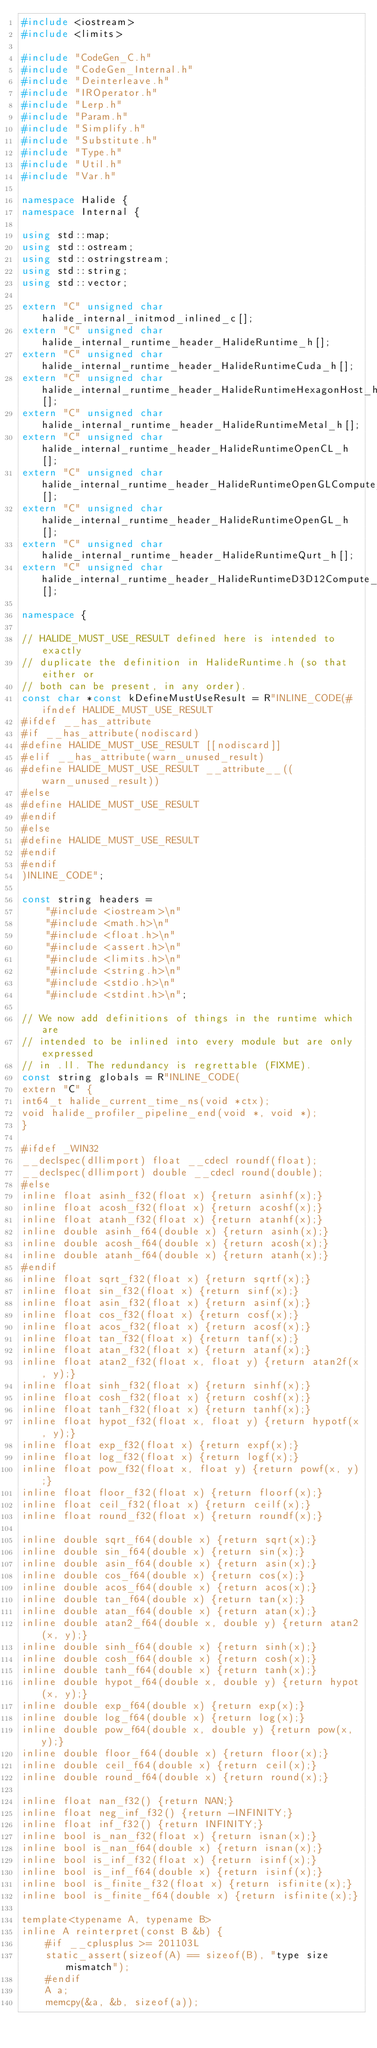Convert code to text. <code><loc_0><loc_0><loc_500><loc_500><_C++_>#include <iostream>
#include <limits>

#include "CodeGen_C.h"
#include "CodeGen_Internal.h"
#include "Deinterleave.h"
#include "IROperator.h"
#include "Lerp.h"
#include "Param.h"
#include "Simplify.h"
#include "Substitute.h"
#include "Type.h"
#include "Util.h"
#include "Var.h"

namespace Halide {
namespace Internal {

using std::map;
using std::ostream;
using std::ostringstream;
using std::string;
using std::vector;

extern "C" unsigned char halide_internal_initmod_inlined_c[];
extern "C" unsigned char halide_internal_runtime_header_HalideRuntime_h[];
extern "C" unsigned char halide_internal_runtime_header_HalideRuntimeCuda_h[];
extern "C" unsigned char halide_internal_runtime_header_HalideRuntimeHexagonHost_h[];
extern "C" unsigned char halide_internal_runtime_header_HalideRuntimeMetal_h[];
extern "C" unsigned char halide_internal_runtime_header_HalideRuntimeOpenCL_h[];
extern "C" unsigned char halide_internal_runtime_header_HalideRuntimeOpenGLCompute_h[];
extern "C" unsigned char halide_internal_runtime_header_HalideRuntimeOpenGL_h[];
extern "C" unsigned char halide_internal_runtime_header_HalideRuntimeQurt_h[];
extern "C" unsigned char halide_internal_runtime_header_HalideRuntimeD3D12Compute_h[];

namespace {

// HALIDE_MUST_USE_RESULT defined here is intended to exactly
// duplicate the definition in HalideRuntime.h (so that either or
// both can be present, in any order).
const char *const kDefineMustUseResult = R"INLINE_CODE(#ifndef HALIDE_MUST_USE_RESULT
#ifdef __has_attribute
#if __has_attribute(nodiscard)
#define HALIDE_MUST_USE_RESULT [[nodiscard]]
#elif __has_attribute(warn_unused_result)
#define HALIDE_MUST_USE_RESULT __attribute__((warn_unused_result))
#else
#define HALIDE_MUST_USE_RESULT
#endif
#else
#define HALIDE_MUST_USE_RESULT
#endif
#endif
)INLINE_CODE";

const string headers =
    "#include <iostream>\n"
    "#include <math.h>\n"
    "#include <float.h>\n"
    "#include <assert.h>\n"
    "#include <limits.h>\n"
    "#include <string.h>\n"
    "#include <stdio.h>\n"
    "#include <stdint.h>\n";

// We now add definitions of things in the runtime which are
// intended to be inlined into every module but are only expressed
// in .ll. The redundancy is regrettable (FIXME).
const string globals = R"INLINE_CODE(
extern "C" {
int64_t halide_current_time_ns(void *ctx);
void halide_profiler_pipeline_end(void *, void *);
}

#ifdef _WIN32
__declspec(dllimport) float __cdecl roundf(float);
__declspec(dllimport) double __cdecl round(double);
#else
inline float asinh_f32(float x) {return asinhf(x);}
inline float acosh_f32(float x) {return acoshf(x);}
inline float atanh_f32(float x) {return atanhf(x);}
inline double asinh_f64(double x) {return asinh(x);}
inline double acosh_f64(double x) {return acosh(x);}
inline double atanh_f64(double x) {return atanh(x);}
#endif
inline float sqrt_f32(float x) {return sqrtf(x);}
inline float sin_f32(float x) {return sinf(x);}
inline float asin_f32(float x) {return asinf(x);}
inline float cos_f32(float x) {return cosf(x);}
inline float acos_f32(float x) {return acosf(x);}
inline float tan_f32(float x) {return tanf(x);}
inline float atan_f32(float x) {return atanf(x);}
inline float atan2_f32(float x, float y) {return atan2f(x, y);}
inline float sinh_f32(float x) {return sinhf(x);}
inline float cosh_f32(float x) {return coshf(x);}
inline float tanh_f32(float x) {return tanhf(x);}
inline float hypot_f32(float x, float y) {return hypotf(x, y);}
inline float exp_f32(float x) {return expf(x);}
inline float log_f32(float x) {return logf(x);}
inline float pow_f32(float x, float y) {return powf(x, y);}
inline float floor_f32(float x) {return floorf(x);}
inline float ceil_f32(float x) {return ceilf(x);}
inline float round_f32(float x) {return roundf(x);}

inline double sqrt_f64(double x) {return sqrt(x);}
inline double sin_f64(double x) {return sin(x);}
inline double asin_f64(double x) {return asin(x);}
inline double cos_f64(double x) {return cos(x);}
inline double acos_f64(double x) {return acos(x);}
inline double tan_f64(double x) {return tan(x);}
inline double atan_f64(double x) {return atan(x);}
inline double atan2_f64(double x, double y) {return atan2(x, y);}
inline double sinh_f64(double x) {return sinh(x);}
inline double cosh_f64(double x) {return cosh(x);}
inline double tanh_f64(double x) {return tanh(x);}
inline double hypot_f64(double x, double y) {return hypot(x, y);}
inline double exp_f64(double x) {return exp(x);}
inline double log_f64(double x) {return log(x);}
inline double pow_f64(double x, double y) {return pow(x, y);}
inline double floor_f64(double x) {return floor(x);}
inline double ceil_f64(double x) {return ceil(x);}
inline double round_f64(double x) {return round(x);}

inline float nan_f32() {return NAN;}
inline float neg_inf_f32() {return -INFINITY;}
inline float inf_f32() {return INFINITY;}
inline bool is_nan_f32(float x) {return isnan(x);}
inline bool is_nan_f64(double x) {return isnan(x);}
inline bool is_inf_f32(float x) {return isinf(x);}
inline bool is_inf_f64(double x) {return isinf(x);}
inline bool is_finite_f32(float x) {return isfinite(x);}
inline bool is_finite_f64(double x) {return isfinite(x);}

template<typename A, typename B>
inline A reinterpret(const B &b) {
    #if __cplusplus >= 201103L
    static_assert(sizeof(A) == sizeof(B), "type size mismatch");
    #endif
    A a;
    memcpy(&a, &b, sizeof(a));</code> 